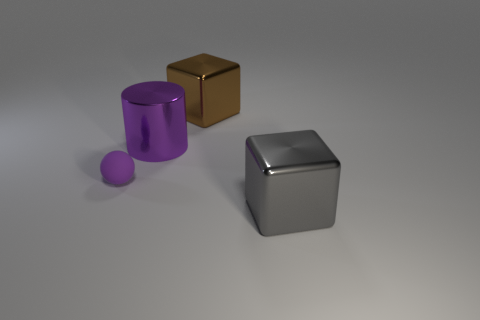Add 3 tiny blue shiny balls. How many objects exist? 7 Subtract 0 blue cylinders. How many objects are left? 4 Subtract all red balls. Subtract all cyan blocks. How many balls are left? 1 Subtract all purple rubber objects. Subtract all brown matte blocks. How many objects are left? 3 Add 4 purple cylinders. How many purple cylinders are left? 5 Add 1 cubes. How many cubes exist? 3 